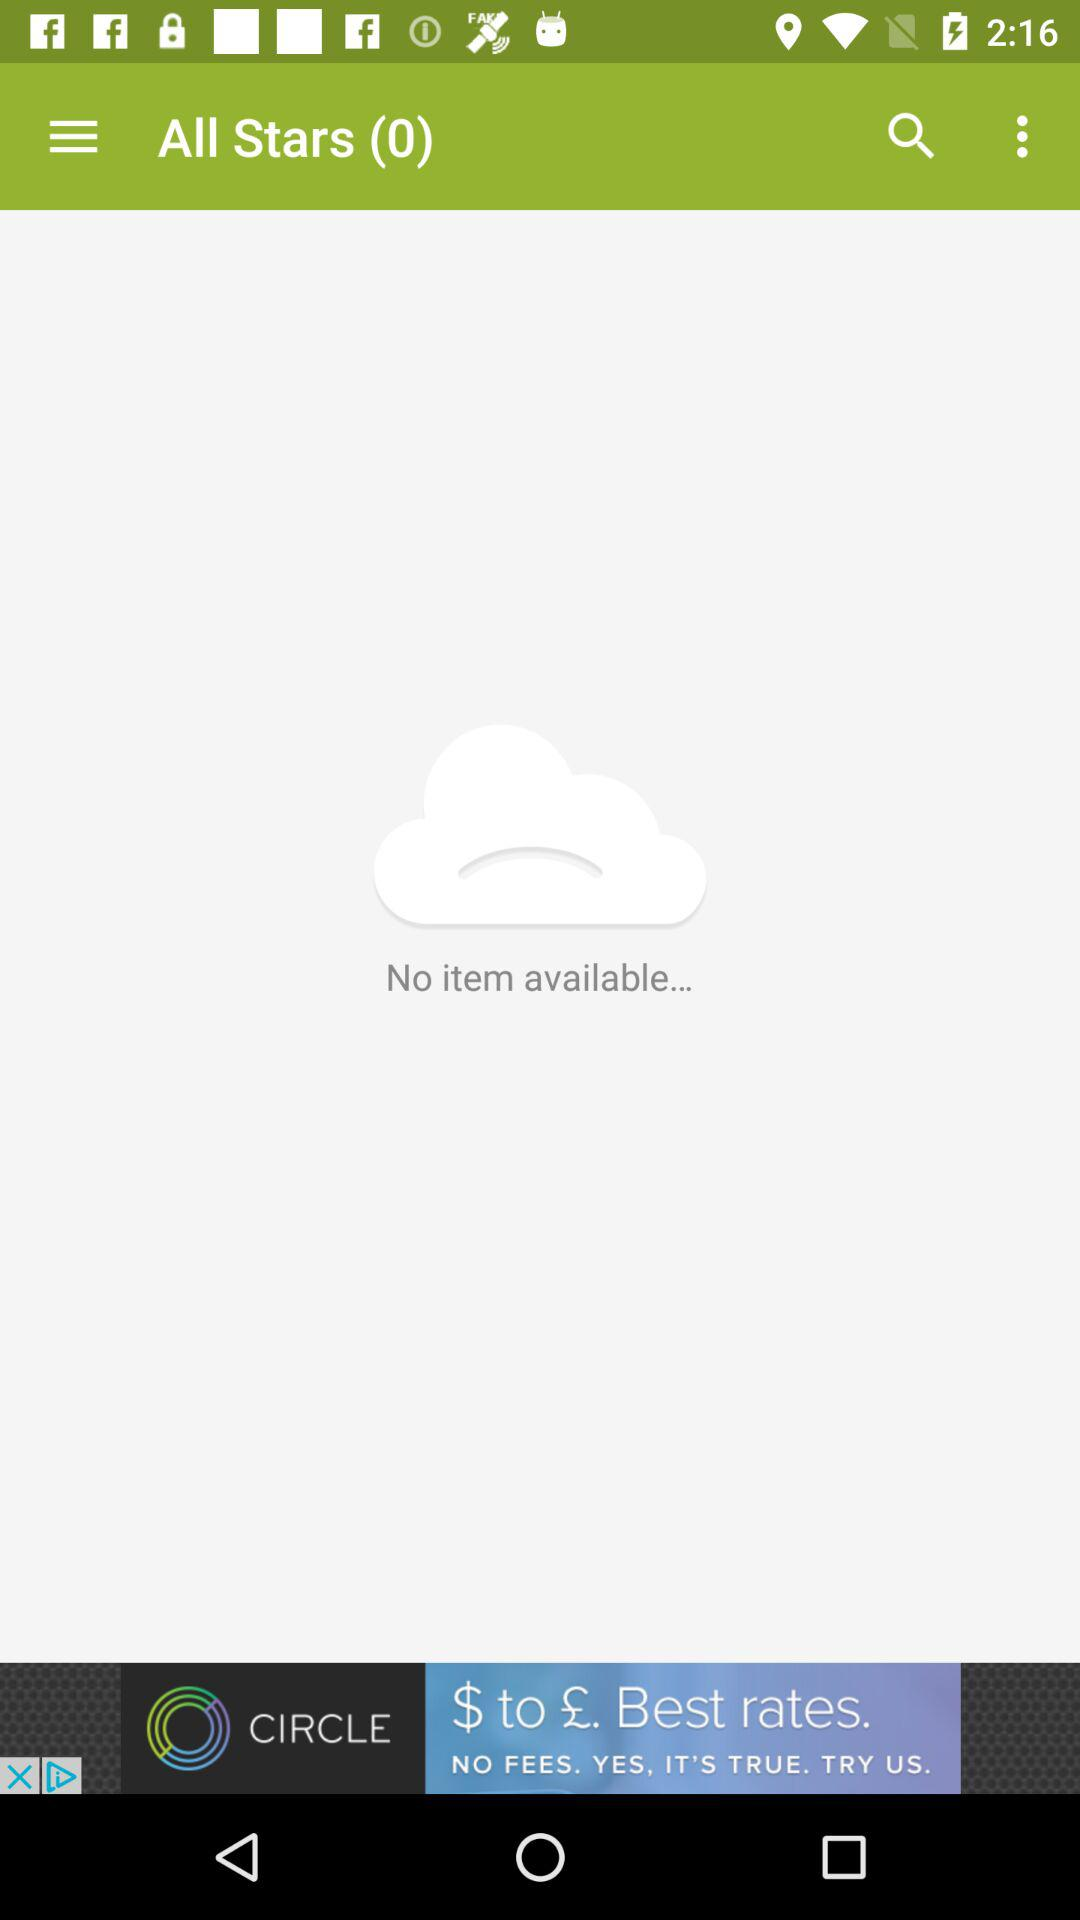Is there any item available on the screen? There is no item available on the screen. 